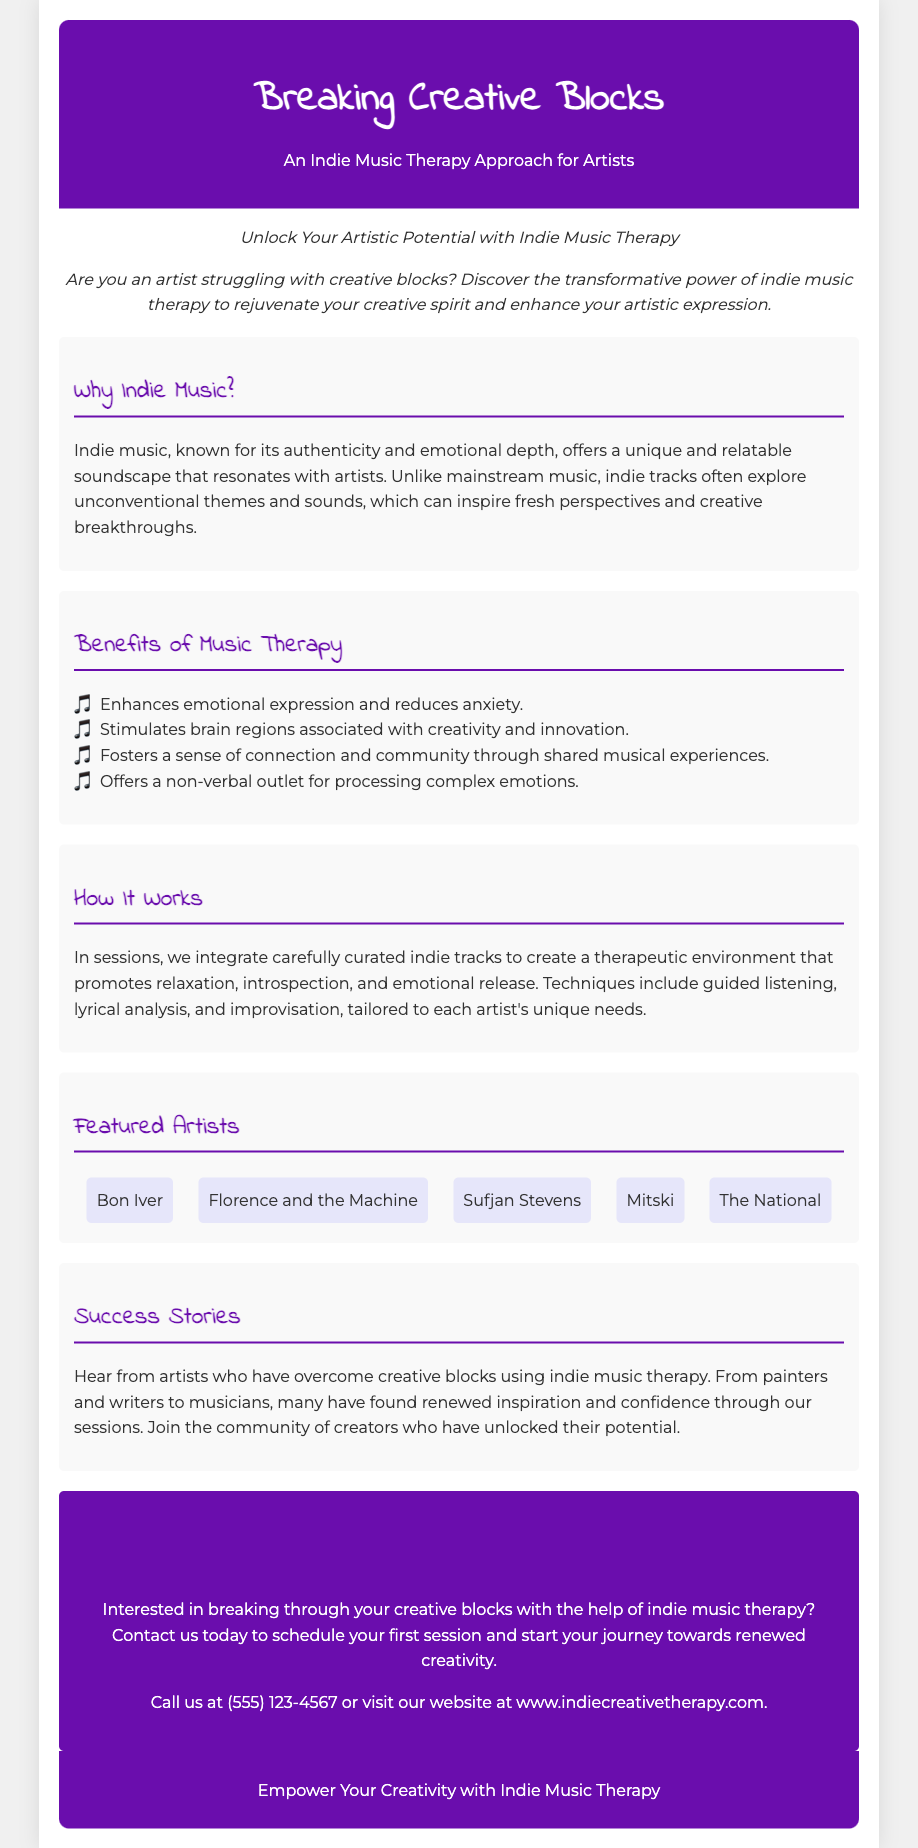What is the title of the flyer? The title of the flyer is prominently displayed at the top.
Answer: Breaking Creative Blocks Who is the target audience for this approach? The document specifically mentions artists struggling with creative blocks.
Answer: Artists What are two benefits of music therapy mentioned? The document lists multiple benefits, two of which are highlighted in a bulleted list.
Answer: Enhances emotional expression and reduces anxiety What type of music does the therapy focus on? The introduction emphasizes the focus on a specific genre of music.
Answer: Indie music Which artist is NOT featured in the document? The list of featured artists includes several names; we need to identify a missing one not listed.
Answer: (any valid indie artist not listed e.g., "Taylor Swift") What techniques are mentioned in the therapy sessions? The document outlines various techniques as part of the therapy process.
Answer: Guided listening, lyrical analysis, and improvisation What is the call to action in the flyer? The flyer encourages a specific next step to take.
Answer: Contact us today to schedule your first session What is the contact number provided? The document includes a specific phone number for contact.
Answer: (555) 123-4567 What color scheme is predominantly used in the document? The document's design features a consistent color theme throughout.
Answer: Purple and white 